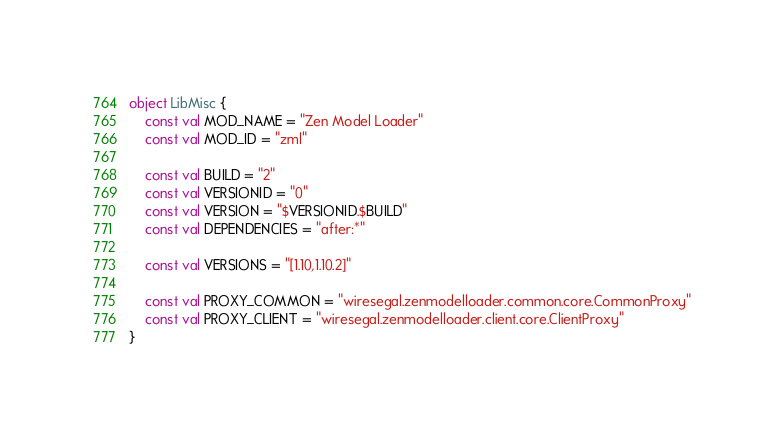Convert code to text. <code><loc_0><loc_0><loc_500><loc_500><_Kotlin_>
object LibMisc {
    const val MOD_NAME = "Zen Model Loader"
    const val MOD_ID = "zml"

    const val BUILD = "2"
    const val VERSIONID = "0"
    const val VERSION = "$VERSIONID.$BUILD"
    const val DEPENDENCIES = "after:*"

    const val VERSIONS = "[1.10,1.10.2]"

    const val PROXY_COMMON = "wiresegal.zenmodelloader.common.core.CommonProxy"
    const val PROXY_CLIENT = "wiresegal.zenmodelloader.client.core.ClientProxy"
}
</code> 